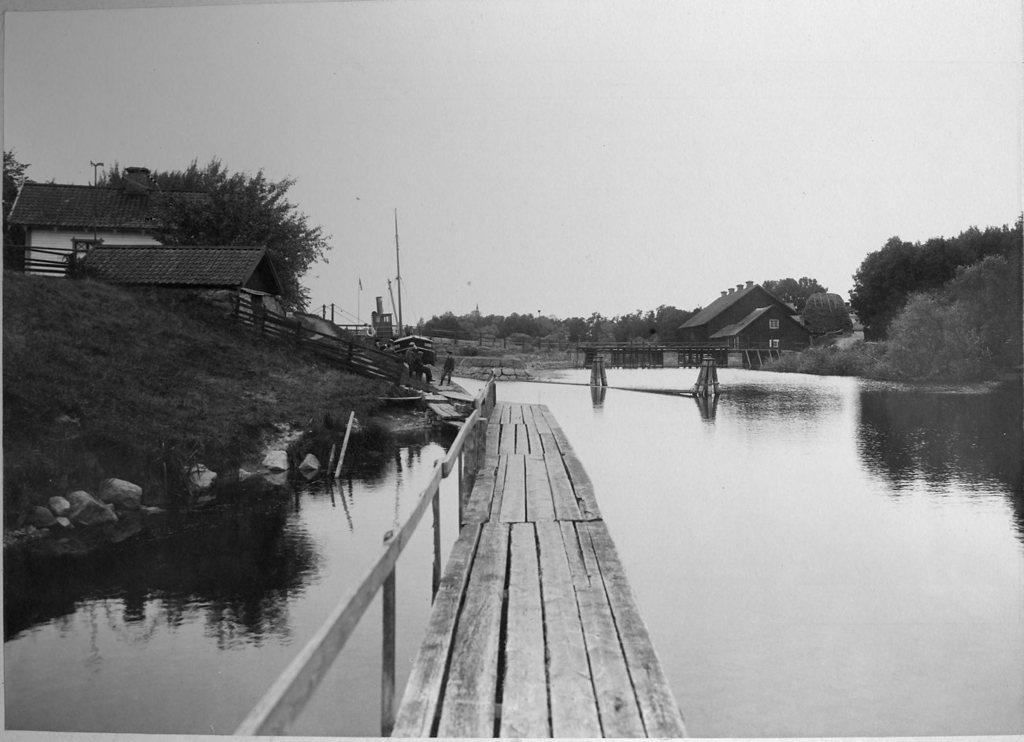What is the main structure in the center of the image? There is a wooden dock in the center of the image. What can be seen in the background of the image? In the background of the image, there are houses, trees, people, poles, stones, another dock, and the sky. What type of surface is visible near the wooden dock? Water is visible in the image near the wooden dock. What type of spring is visible in the image? There is no spring present in the image. Can you tell me the name of the secretary in the image? There is no secretary present in the image. Who is the friend standing next to the person on the dock? There is no friend visible in the image; only people in the background are mentioned. 